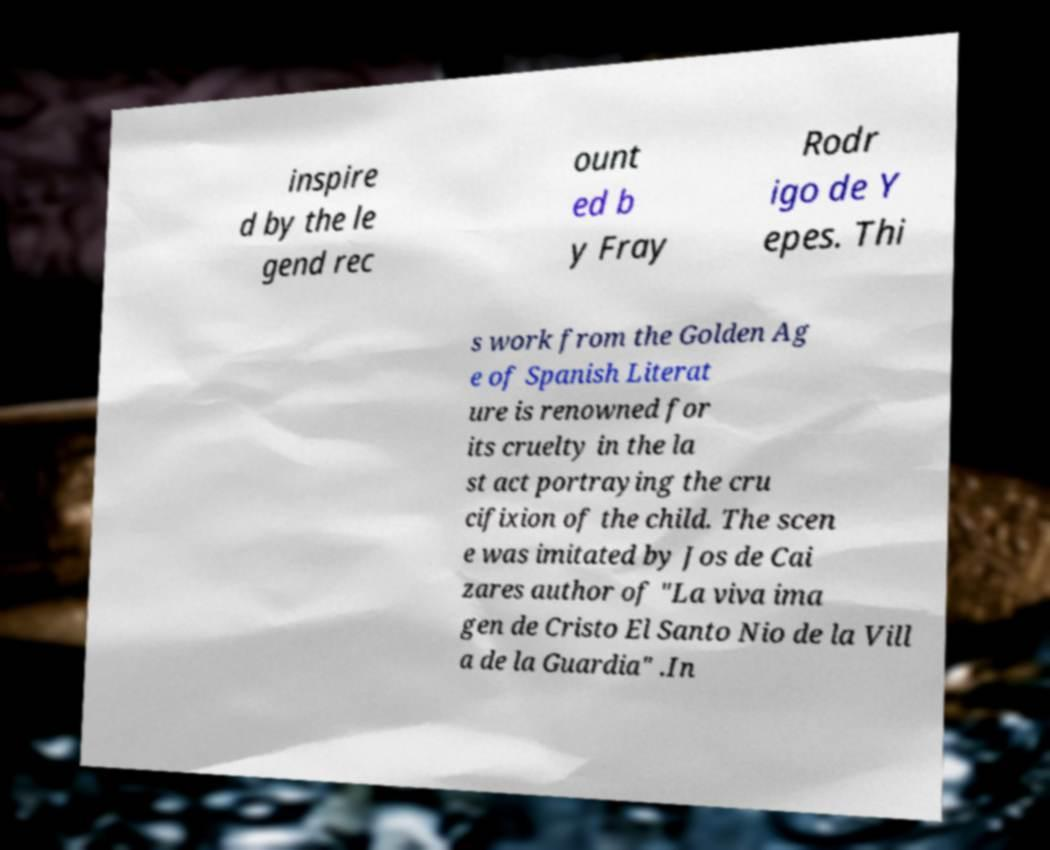Can you read and provide the text displayed in the image?This photo seems to have some interesting text. Can you extract and type it out for me? inspire d by the le gend rec ount ed b y Fray Rodr igo de Y epes. Thi s work from the Golden Ag e of Spanish Literat ure is renowned for its cruelty in the la st act portraying the cru cifixion of the child. The scen e was imitated by Jos de Cai zares author of "La viva ima gen de Cristo El Santo Nio de la Vill a de la Guardia" .In 